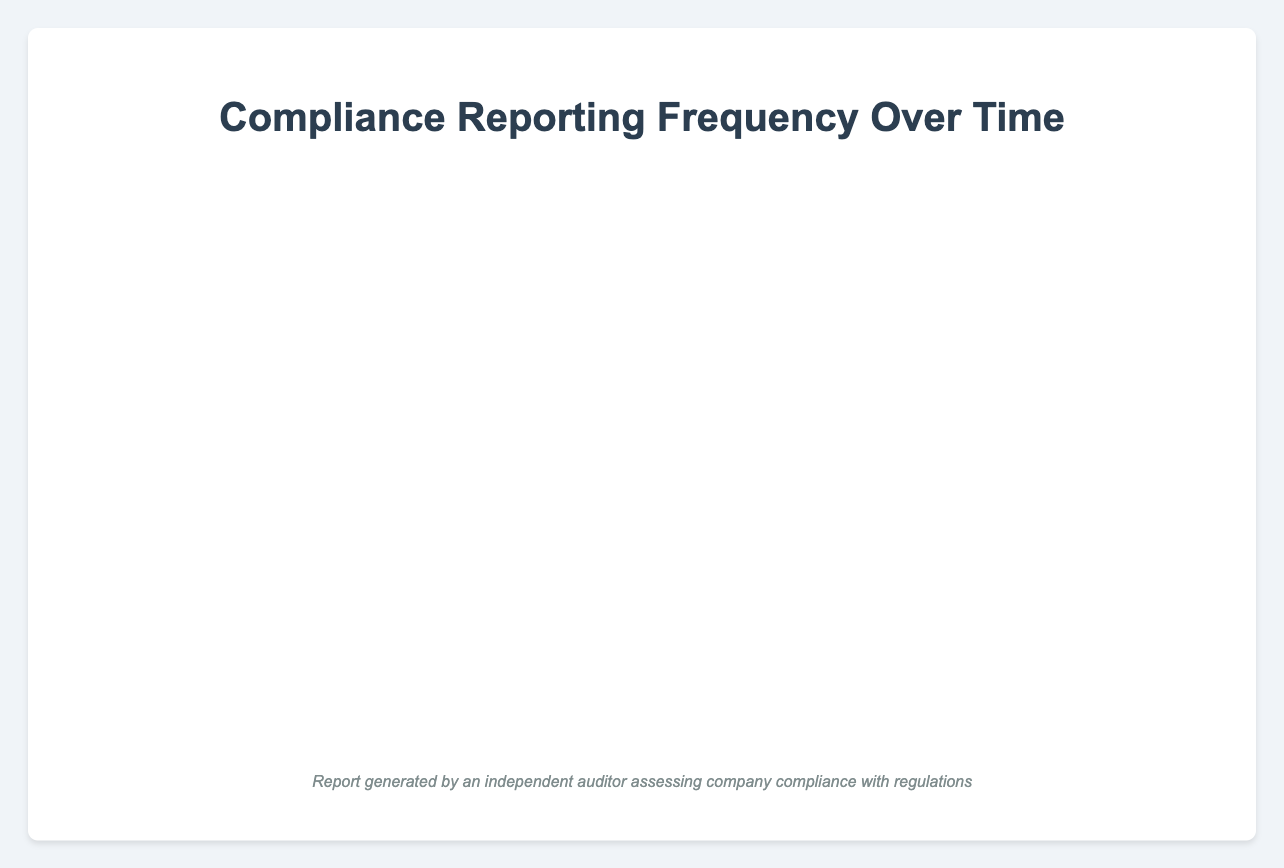How has the reporting frequency of Acme Corp changed from January 2020 to June 2022? First, note the values for Acme Corp in January 2020 (4), June 2020 (5), January 2021 (6), June 2021 (7), January 2022 (8), and June 2022 (9). The frequency increased progressively over each period.
Answer: It increased from 4 to 9 Among the three companies, which one had the highest number of report submissions in June 2022? Check the submissions for each company in June 2022: Acme Corp (9), Beta Industries (7), Gamma Enterprises (7). Acme Corp had the highest number of submissions.
Answer: Acme Corp What is the average number of report submissions for Gamma Enterprises across all the periods? Add the values for Gamma Enterprises (2, 4, 3, 5, 6, 7) for all periods, which equates to 27. There are 6 periods, so the average is 27/6 = 4.5.
Answer: 4.5 During which period did Beta Industries experience an increase in the report submissions compared to the previous period? Beta Industries' submissions: January 2020 (3), June 2020 (3), January 2021 (5), June 2021 (5), January 2022 (6), June 2022 (7). The increases occurred in January 2021, January 2022, and June 2022 compared to their preceding periods.
Answer: January 2021, January 2022, June 2022 Which company showed the most noticeable increase in report submissions from January 2020 to June 2022, and by how much? Calculate the increase for each company from January 2020 to June 2022. Acme Corp: 9 - 4 = 5, Beta Industries: 7 - 3 = 4, Gamma Enterprises: 7 - 2 = 5. Acme Corp and Gamma Enterprises both increased by 5.
Answer: Acme Corp and Gamma Enterprises by 5 Compare Acme Corp and Gamma Enterprises to determine which had a higher trend growth over the given periods. Observe the slope of the line for both companies. Acme Corp grows steadily each period (4 to 9), whereas Gamma Enterprises has periods with no increase (2 to 7). Acme Corp shows a more consistent and higher trend growth.
Answer: Acme Corp Which months saw no change in the number of report submissions for Beta Industries? Examine Beta Industries' line: January 2020 (3) to June 2020 (3), and June 2021 (5) to January 2021 (5), submissions remained unchanged.
Answer: June 2020 and January 2021 How does the reporting frequency of Gamma Enterprises in June 2020 compare with the reporting frequency in January 2021? Gamma Enterprises had 4 submissions in June 2020 and 3 submissions in January 2021. The frequency decreased by 1.
Answer: It decreased by 1 What is the difference in report submissions between Acme Corp and Beta Industries in January 2022? Acme Corp had 8 submissions, and Beta Industries had 6 submissions. The difference is 8 - 6 = 2.
Answer: 2 